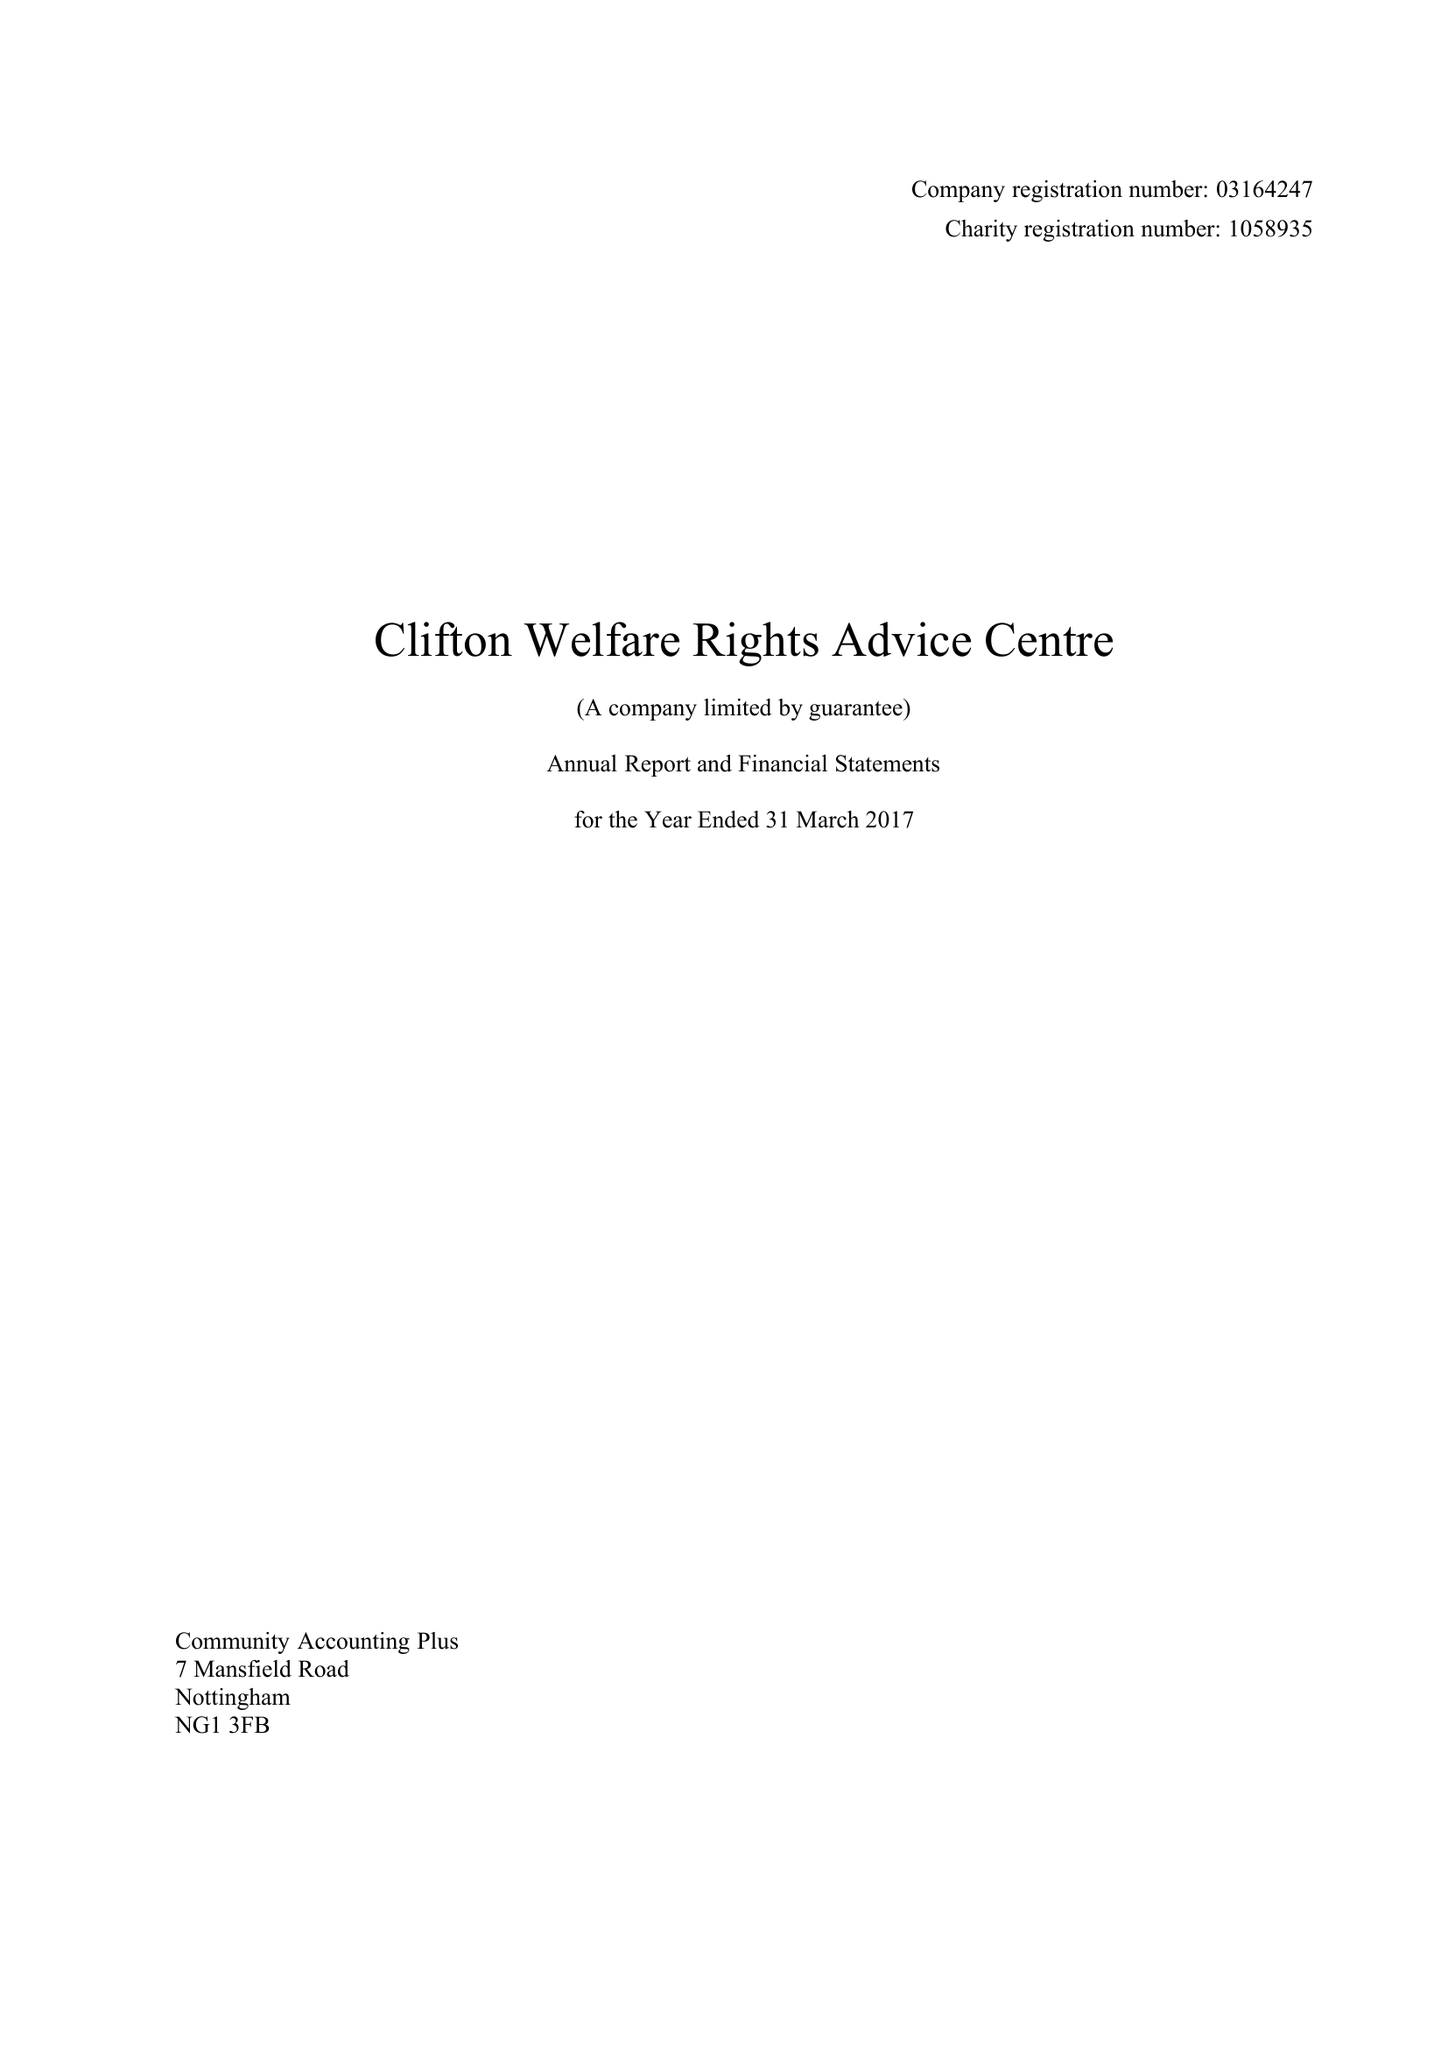What is the value for the charity_name?
Answer the question using a single word or phrase. Clifton Welfare Rights Advice Centre 